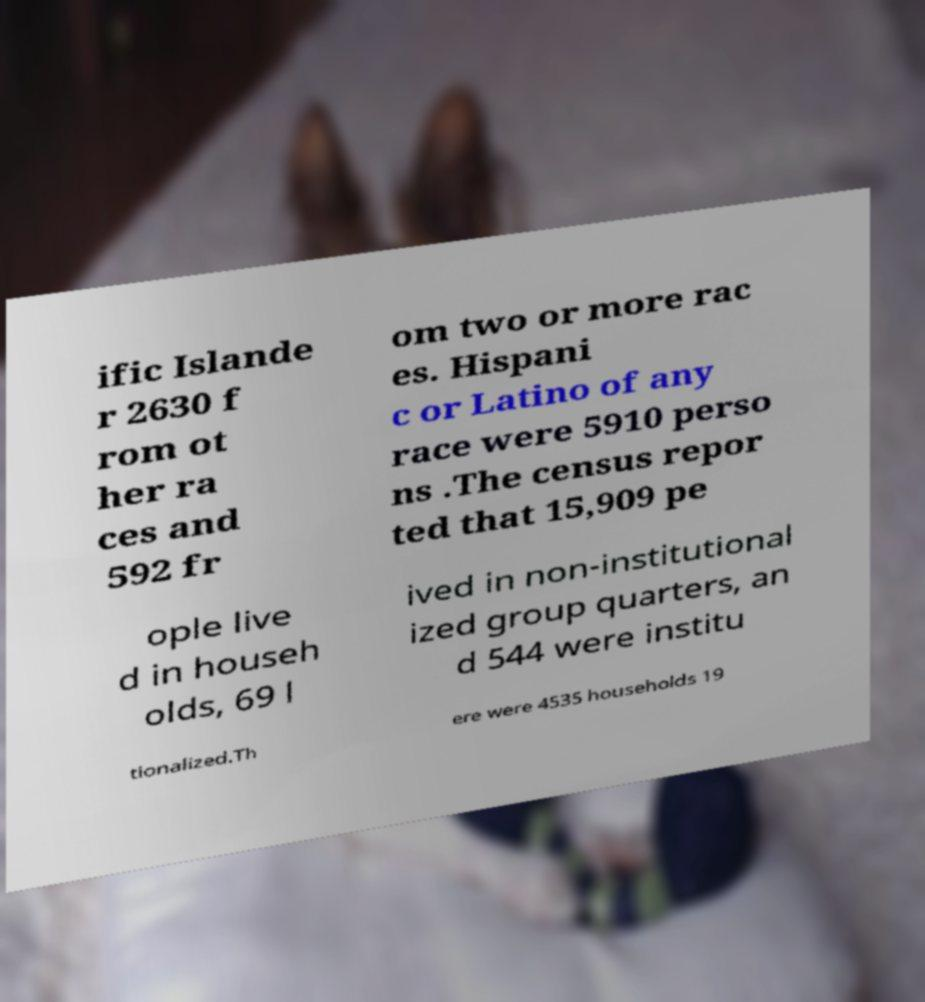Please read and relay the text visible in this image. What does it say? ific Islande r 2630 f rom ot her ra ces and 592 fr om two or more rac es. Hispani c or Latino of any race were 5910 perso ns .The census repor ted that 15,909 pe ople live d in househ olds, 69 l ived in non-institutional ized group quarters, an d 544 were institu tionalized.Th ere were 4535 households 19 